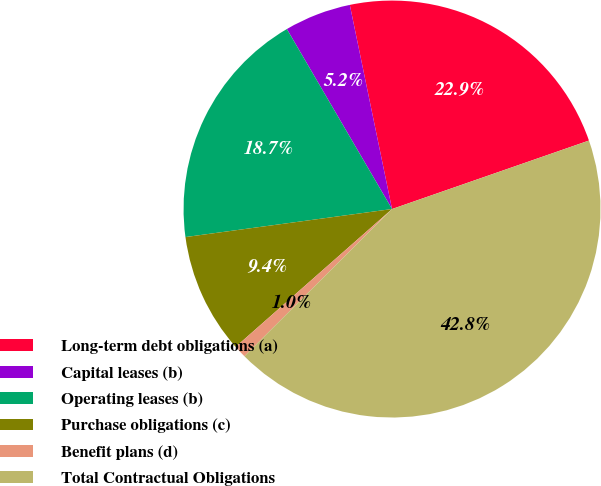Convert chart. <chart><loc_0><loc_0><loc_500><loc_500><pie_chart><fcel>Long-term debt obligations (a)<fcel>Capital leases (b)<fcel>Operating leases (b)<fcel>Purchase obligations (c)<fcel>Benefit plans (d)<fcel>Total Contractual Obligations<nl><fcel>22.92%<fcel>5.17%<fcel>18.73%<fcel>9.35%<fcel>0.98%<fcel>42.85%<nl></chart> 